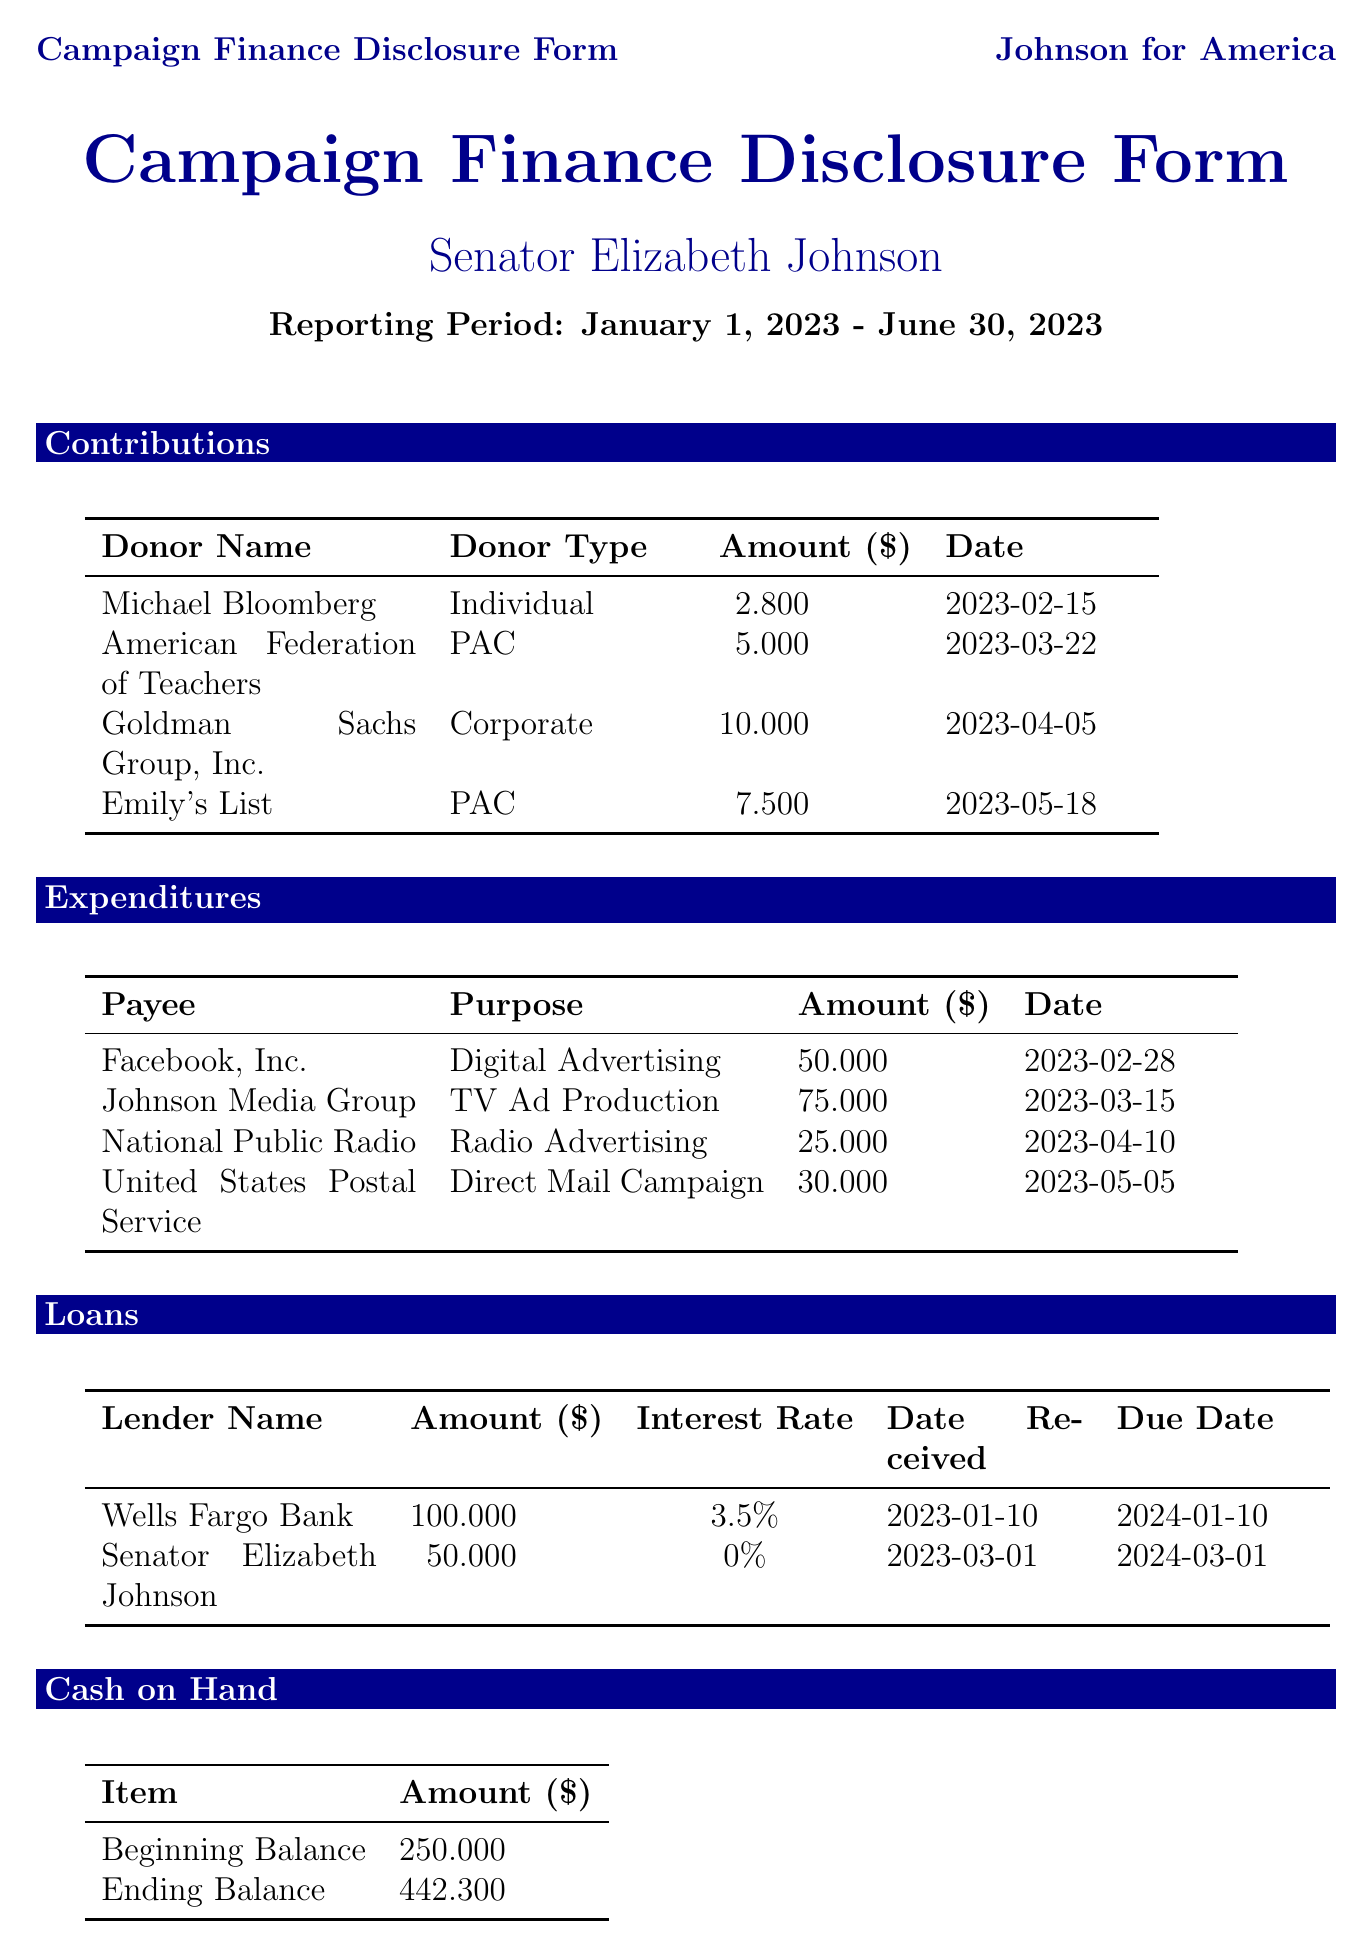What is the candidate's name? The candidate's name is stated at the top of the document under the title.
Answer: Senator Elizabeth Johnson What is the total amount of contributions received? The contributions listed total to the sums of $2800, $5000, $10000, and $7500.
Answer: $20500 What was the purpose of the expenditure to Facebook, Inc.? The purpose is clearly stated next to the payee in the expenditures section.
Answer: Digital Advertising Who provided a loan at a zero percent interest rate? The lender with a zero percent interest rate is mentioned in the loans section.
Answer: Senator Elizabeth Johnson What is the ending balance of cash on hand? The ending balance is found in the cash on hand section of the document.
Answer: $442300 What is the interest rate for the loan from Wells Fargo Bank? The interest rate for this loan is noted in the loans section.
Answer: 3.5% How many PAC contributions were made in total? The document lists the types of donors, which helps to identify the total PAC contributions.
Answer: 2 